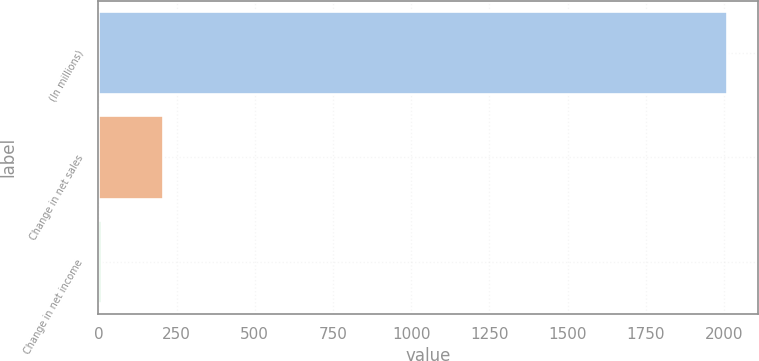Convert chart to OTSL. <chart><loc_0><loc_0><loc_500><loc_500><bar_chart><fcel>(In millions)<fcel>Change in net sales<fcel>Change in net income<nl><fcel>2008<fcel>208<fcel>8<nl></chart> 